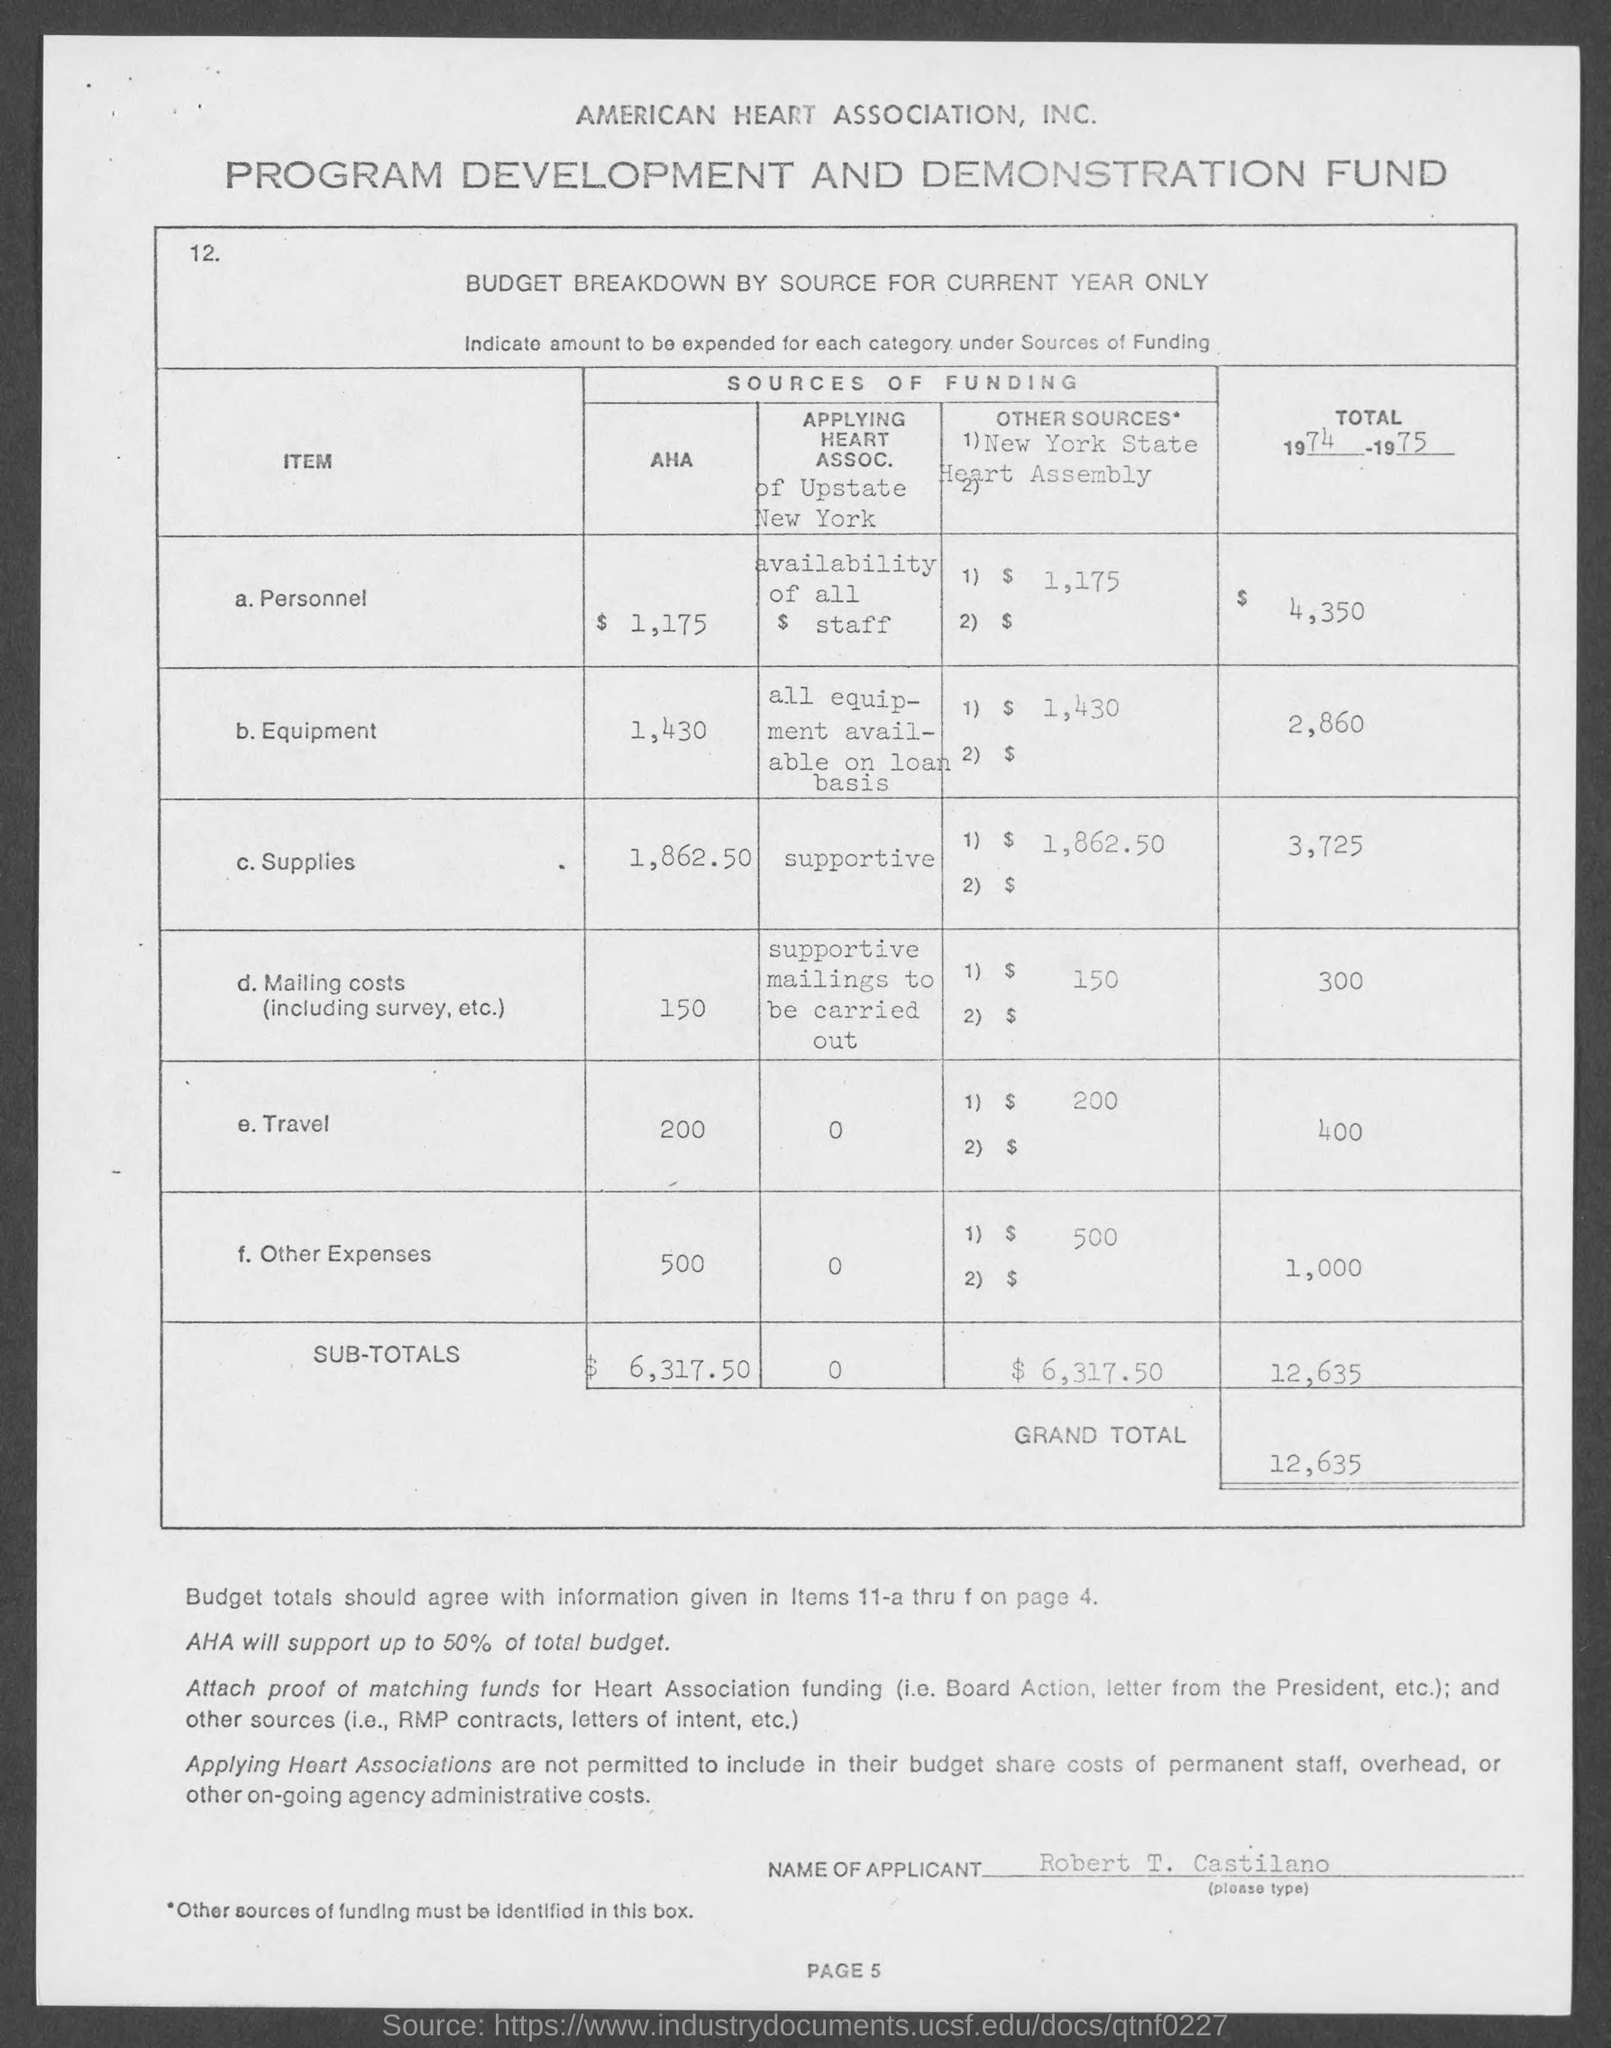Draw attention to some important aspects in this diagram. The total cost for travel in 1974 and 1975 is 400. The total for 1974 and 1975 for Personnel is $4,350. The grand total is 12,635. The subtotal for Other sources is $6,317.50. The total for 1974 and 1975 is 12,635. 